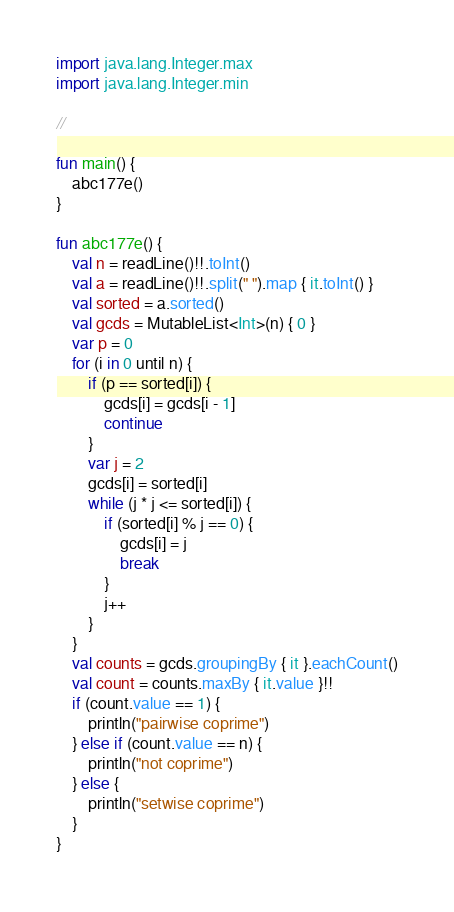<code> <loc_0><loc_0><loc_500><loc_500><_Kotlin_>import java.lang.Integer.max
import java.lang.Integer.min

//

fun main() {
    abc177e()
}

fun abc177e() {
    val n = readLine()!!.toInt()
    val a = readLine()!!.split(" ").map { it.toInt() }
    val sorted = a.sorted()
    val gcds = MutableList<Int>(n) { 0 }
    var p = 0
    for (i in 0 until n) {
        if (p == sorted[i]) {
            gcds[i] = gcds[i - 1]
            continue
        }
        var j = 2
        gcds[i] = sorted[i]
        while (j * j <= sorted[i]) {
            if (sorted[i] % j == 0) {
                gcds[i] = j
                break
            }
            j++
        }
    }
    val counts = gcds.groupingBy { it }.eachCount()
    val count = counts.maxBy { it.value }!!
    if (count.value == 1) {
        println("pairwise coprime")
    } else if (count.value == n) {
        println("not coprime")
    } else {
        println("setwise coprime")
    }
}
</code> 